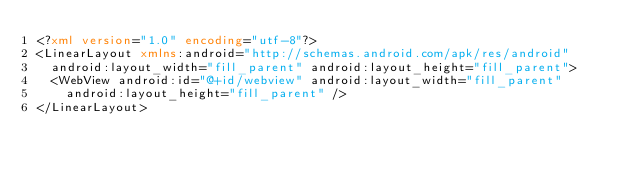Convert code to text. <code><loc_0><loc_0><loc_500><loc_500><_XML_><?xml version="1.0" encoding="utf-8"?>
<LinearLayout xmlns:android="http://schemas.android.com/apk/res/android"
	android:layout_width="fill_parent" android:layout_height="fill_parent">
	<WebView android:id="@+id/webview" android:layout_width="fill_parent"
		android:layout_height="fill_parent" />
</LinearLayout>
</code> 